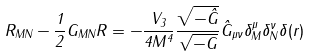<formula> <loc_0><loc_0><loc_500><loc_500>R _ { M N } - \frac { 1 } { 2 } G _ { M N } R = - \frac { V _ { 3 } } { 4 M ^ { 4 } } \frac { \sqrt { - \hat { G } } } { \sqrt { - G } } \hat { G } _ { \mu \nu } \delta ^ { \mu } _ { M } \delta ^ { \nu } _ { N } \delta ( r )</formula> 